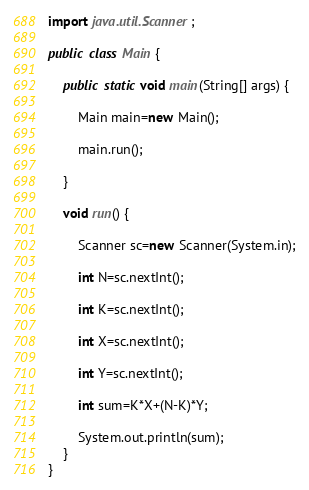<code> <loc_0><loc_0><loc_500><loc_500><_Java_>import java.util.Scanner;

public class Main {

    public static void main(String[] args) {

    	Main main=new Main();

    	main.run();

    }

    void run() {

    	Scanner sc=new Scanner(System.in);

    	int N=sc.nextInt();

    	int K=sc.nextInt();

    	int X=sc.nextInt();

    	int Y=sc.nextInt();

    	int sum=K*X+(N-K)*Y;

    	System.out.println(sum);
    }
}
</code> 